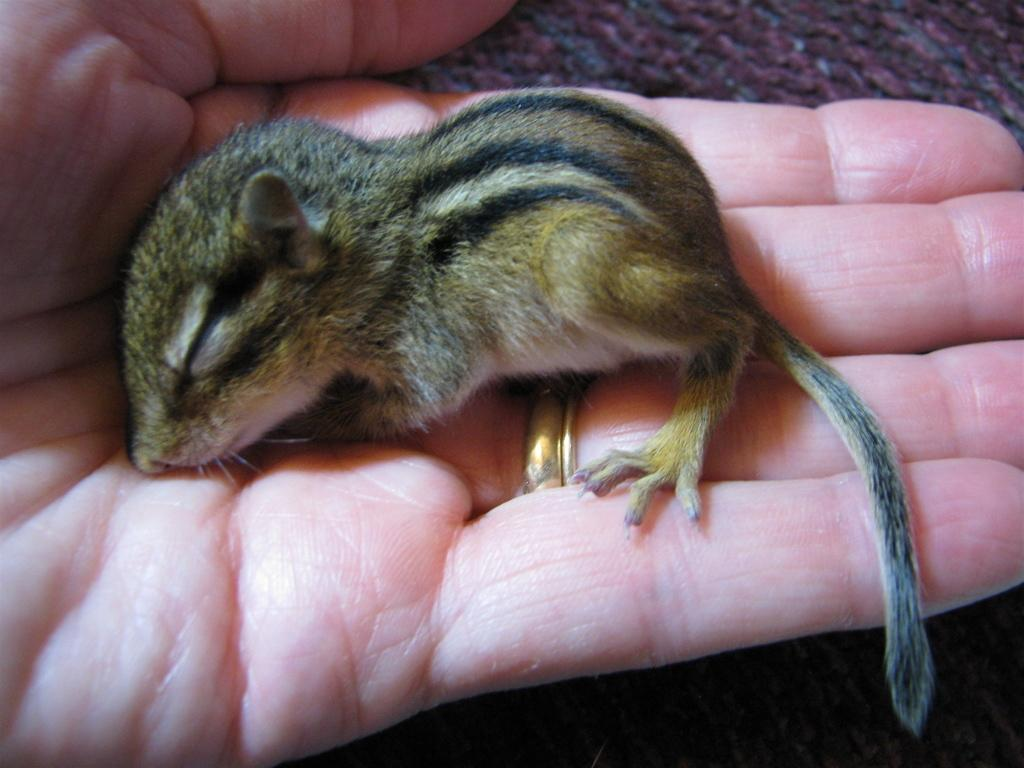What is the person in the image holding? The person is holding a baby squirrel in the image. What can be observed about the background color in the image? The background color is brown. How many snails can be seen crawling on the baby squirrel in the image? There are no snails visible in the image, as it features a person holding a baby squirrel with a brown background. 